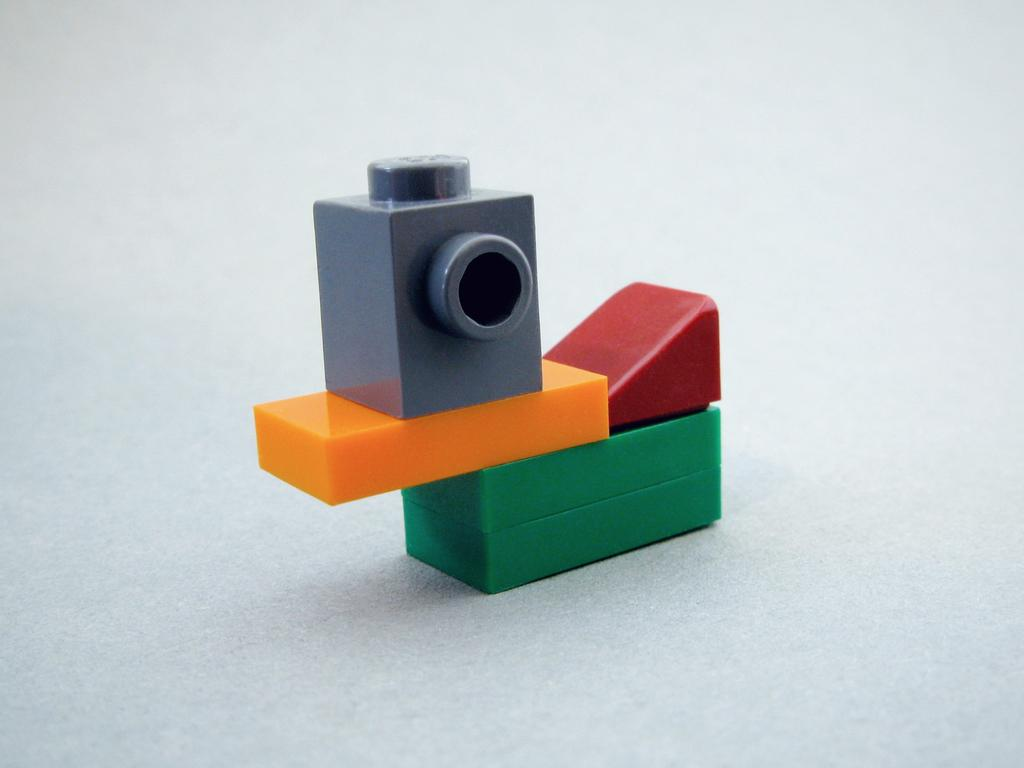What is the main subject of the image? There are blocks in the image. Can you describe the blocks in the image? The blocks are in multiple colors. What is the color of the background in the image? The background of the image is white. What type of chain can be seen connecting the blocks in the image? There is no chain connecting the blocks in the image; the blocks are separate and not connected. 